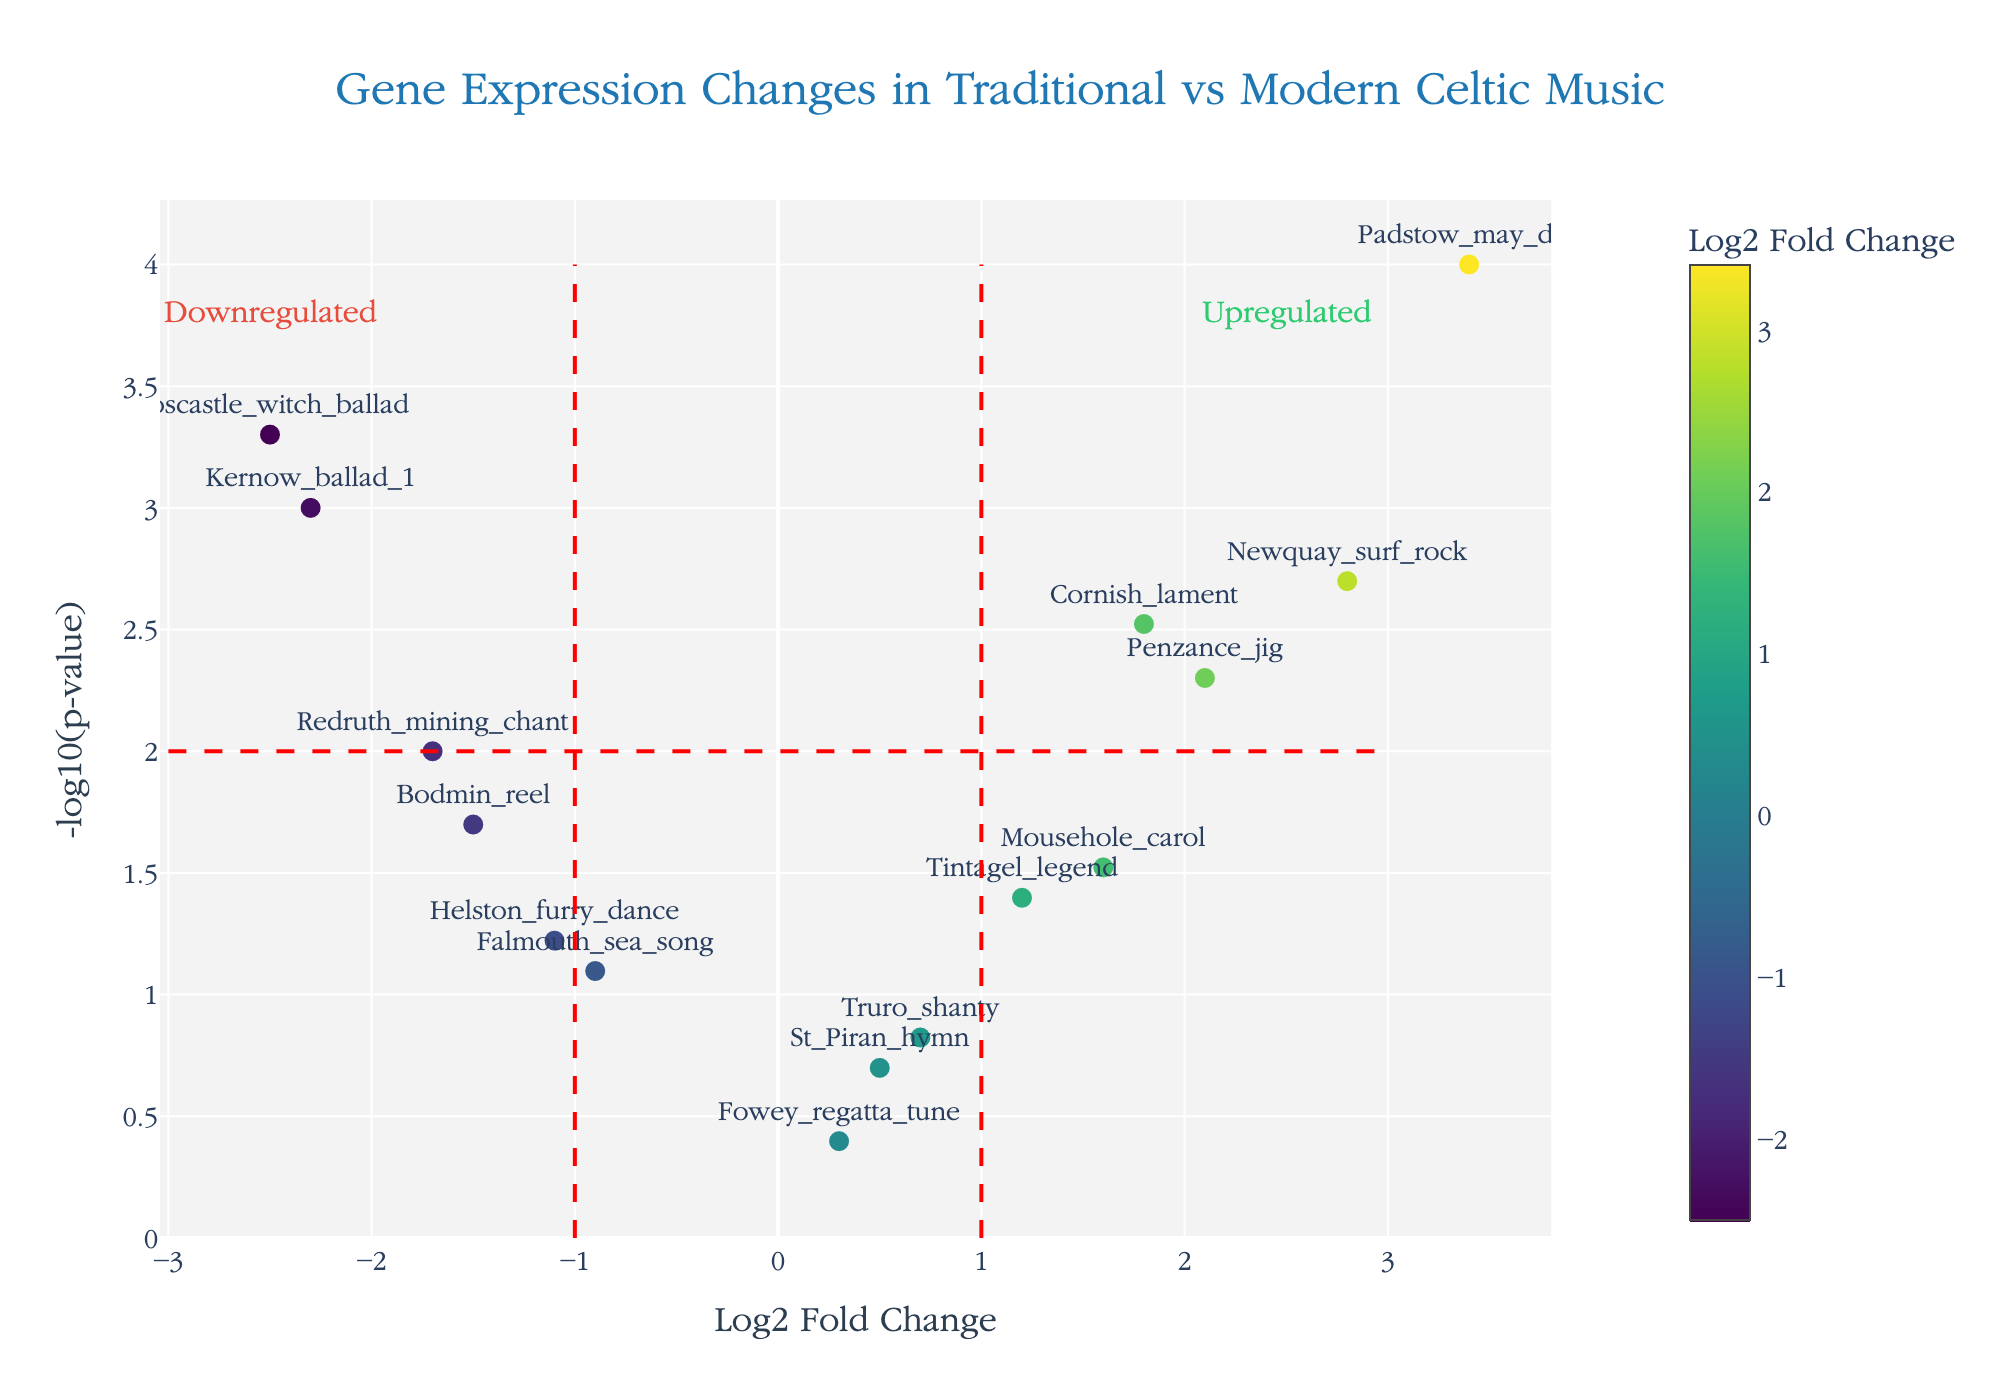What is the title of the plot? The title is usually placed at the top center of the plot. It reads "Gene Expression Changes in Traditional vs Modern Celtic Music".
Answer: Gene Expression Changes in Traditional vs Modern Celtic Music Which gene has the highest -log10(p-value)? Look for the point farthest up the y-axis since higher -log10(p-value) values reflect more strongly significant p-values. The gene "Padstow_may_day" has the highest -log10(p-value).
Answer: Padstow_may_day What is the fold change threshold indicated by the vertical lines? The vertical lines’ position on the x-axis indicates the fold change thresholds. They align with -1 and 1 on the log2 fold change axis.
Answer: ±1 Which genes are classified as upregulated? Upregulated genes have positive log2 fold change values greater than the threshold of 1, and a -log10(p-value) greater than 2. Those genes are "Penzance_jig", "Newquay_surf_rock", and "Padstow_may_day".
Answer: Penzance_jig, Newquay_surf_rock, Padstow_may_day Which gene shows the most significant downregulation? Identify the gene with the lowest log2 fold change (most negative) and a -log10(p-value) greater than 2. The "Boscastle_witch_ballad" has the most significant negative log2 fold change of -2.5.
Answer: Boscastle_witch_ballad How many genes have p-values lower than 0.05? Genes with p-values less than 0.05 will have -log10(p-value) greater than 1.3. Counting these points on the plot reveals there are 9 such genes.
Answer: 9 Of the downregulated genes, which one has the p-value closest to 0.05? Among the genes with negative log2 fold change values, find the one with -log10(p-value) just above 1.3, indicating a p-value close to 0.05. "Helston_furry_dance" is the closest with a -log10(p-value) near the horizontal threshold line.
Answer: Helston_furry_dance How many genes are labeled on the plot? Looking at the figure, count all the distinct gene names shown in text near each point. There are 15 gene names labeled.
Answer: 15 